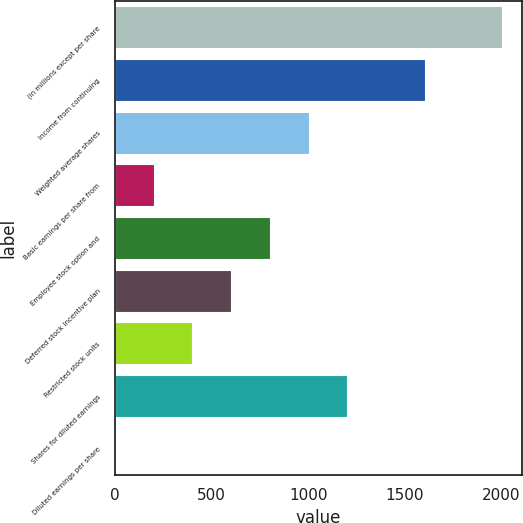Convert chart to OTSL. <chart><loc_0><loc_0><loc_500><loc_500><bar_chart><fcel>(in millions except per share<fcel>Income from continuing<fcel>Weighted average shares<fcel>Basic earnings per share from<fcel>Employee stock option and<fcel>Deferred stock incentive plan<fcel>Restricted stock units<fcel>Shares for diluted earnings<fcel>Diluted earnings per share<nl><fcel>2004<fcel>1603.48<fcel>1002.64<fcel>201.52<fcel>802.36<fcel>602.08<fcel>401.8<fcel>1202.92<fcel>1.24<nl></chart> 